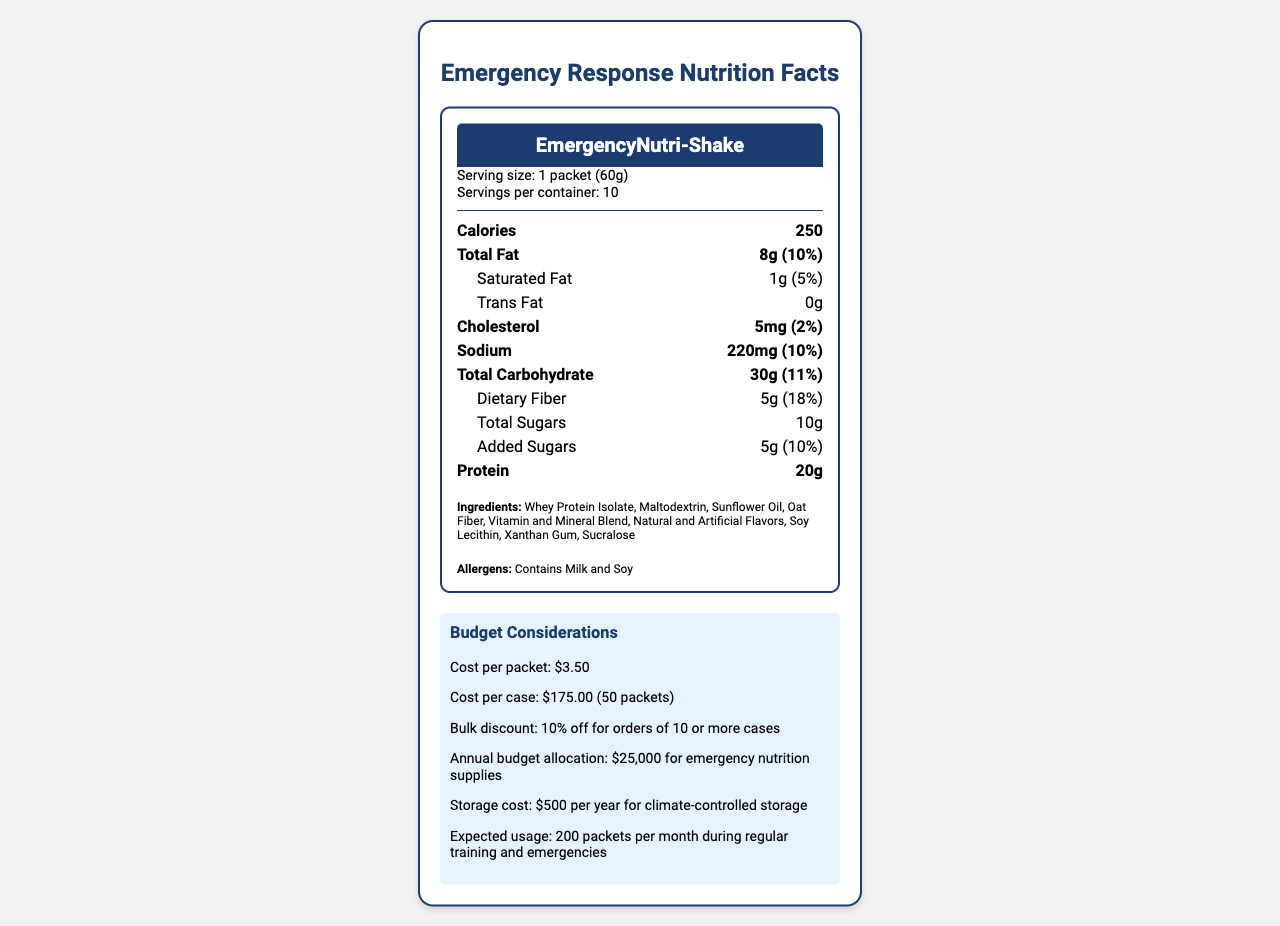how many calories are there per serving? The calories per serving are specified as 250 in the "nutrient-row main-nutrient" section of the label.
Answer: 250 what is the serving size for the EmergencyNutri-Shake? The serving size is listed in the "serving-info" section as "1 packet (60g)."
Answer: 1 packet (60g) how many grams of protein are there in one packet of the shake? The protein content is listed as 20g in the "nutrient-row main-nutrient" section.
Answer: 20g what is the recommended storage instruction for this product? The storage instructions are specified under "storage_instructions."
Answer: Store in a cool, dry place. Use within 3 years of production date. what is the cost per packet? According to the budget information, the cost per packet is $3.50.
Answer: $3.50 which vitamins have a daily value of 25% or more? A. Vitamin A, Vitamin C, Vitamin D B. Thiamin, Riboflavin, Niacin C. Calcium, Iron, Vitamin B12 D. Magnesium, Zinc, Selenium Thiamin, Riboflavin, and Niacin have daily values of 25% or more as mentioned in their respective nutrient details.
Answer: B how long is this product shelf-stable? A. 1 year B. 2 years C. 3 years D. 5 years The document states that the product is shelf-stable for up to 3 years, as per "additional_notes."
Answer: C is this product suitable for people who are allergic to soy? The allergens section indicates that the product contains soy.
Answer: No summarize the document The document provides comprehensive information about the nutritional content, usage, storage, cost, and certifications of the meal replacement shake.
Answer: The document details the nutrition facts for EmergencyNutri-Shake, a meal replacement shake designed for emergency responders. It includes serving size, calories, fat, cholesterol, sodium, carbohydrates, protein, and micronutrient content. The document also lists ingredients, allergens, storage, and preparation instructions, manufacturer and distributor information, certifications, and budget considerations for purchasing and storing the product. what is the exact vitamin C content in one packet? The vitamin C content is listed as 18mg in the "vitamin_c" section.
Answer: 18mg does the product contain any added sugars? The document states that the shake contains 5g of added sugars, as indicated under "added_sugars."
Answer: Yes what is the estimated total annual cost for storage? The budget considerations section lists the storage cost as $500 per year for climate-controlled storage.
Answer: $500 how many packets are expected to be used per month? The expected usage is 200 packets per month during regular training and emergencies, as mentioned in the budget considerations.
Answer: 200 packets what types of certifications does the product have? The certifications are listed as "NSF Certified for Sport," "Kosher," and "Halal."
Answer: NSF Certified for Sport, Kosher, Halal what flavors are used in the product? The ingredients list includes "Natural and Artificial Flavors."
Answer: Natural and Artificial Flavors who is the manufacturer of the EmergencyNutri-Shake? The manufacturer information is provided as EmergencyNutrition Corp.
Answer: EmergencyNutrition Corp. what is the daily value of calcium provided per serving? The daily value for calcium is listed as 20% in the document.
Answer: 20% are there any instructions on preparation? There are preparation instructions which state, "Mix one packet (60g) with 12 fl oz (355 mL) of cold water. Shake well."
Answer: Yes are the emergency nutrition supplies meant to be a sole source of nutrition? The document mentions that it is not intended as a sole source of nutrition, as specified in "additional_notes."
Answer: No will the budget allocation overlook the cost of storage? The document does not provide enough information to conclusively say if the annual budget allocation of $25,000 includes the storage cost.
Answer: Not enough information 